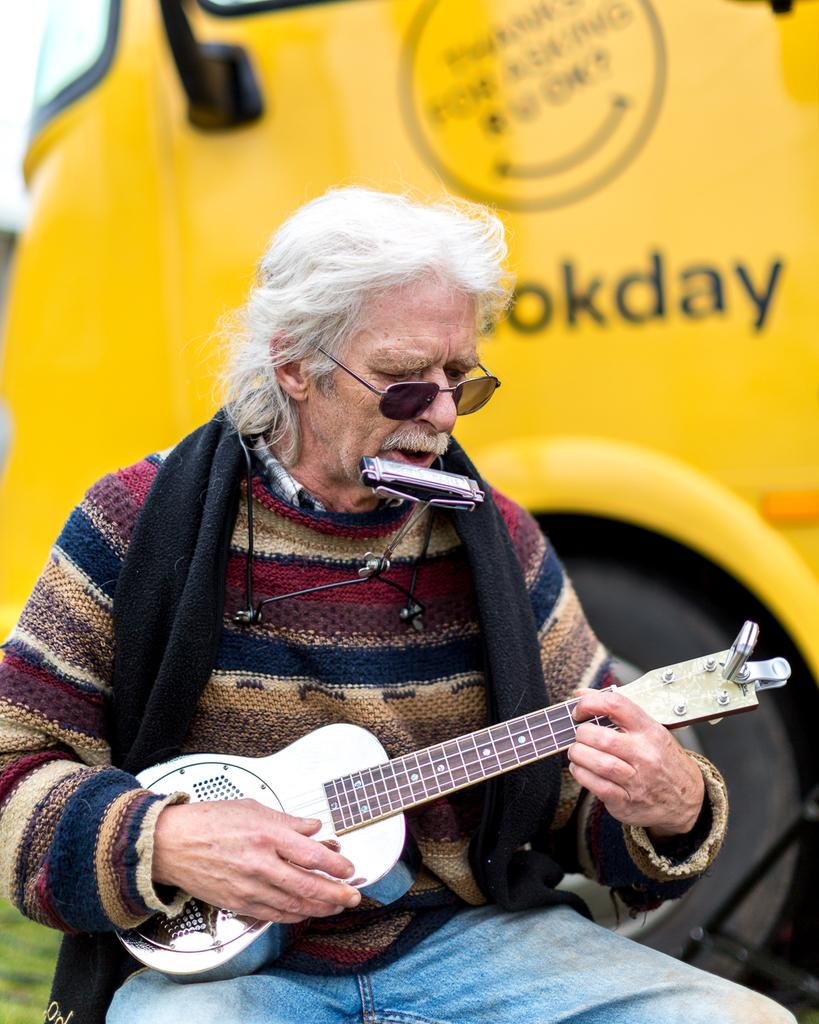What is the person in the image doing? The person is sitting and playing a guitar. What other musical instrument is near the person? There is a mouth organ near the person's mouth. What can be seen behind the person in the image? There is a vehicle present behind the person. What type of bedroom furniture can be seen in the image? There is no bedroom furniture present in the image. What is the person's interest in the image? The image does not provide information about the person's interests. 